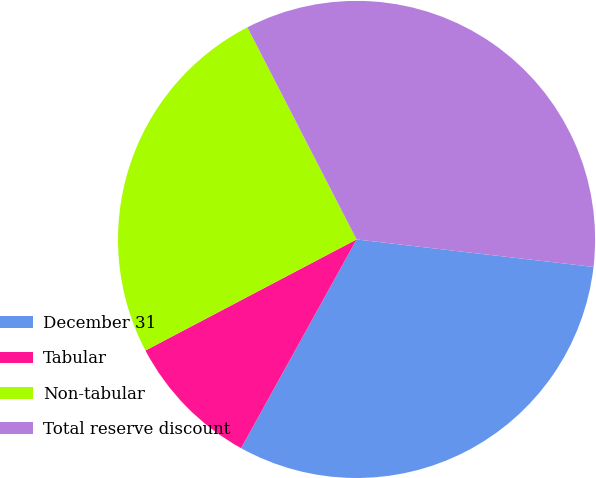<chart> <loc_0><loc_0><loc_500><loc_500><pie_chart><fcel>December 31<fcel>Tabular<fcel>Non-tabular<fcel>Total reserve discount<nl><fcel>31.2%<fcel>9.25%<fcel>25.14%<fcel>34.4%<nl></chart> 